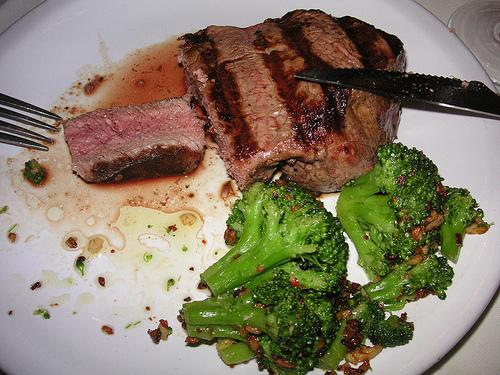Question: how many utensils?
Choices:
A. One.
B. None.
C. Two.
D. Three.
Answer with the letter. Answer: C Question: what is on the plate?
Choices:
A. Beads.
B. Chips.
C. Food.
D. Chicken.
Answer with the letter. Answer: C Question: what is on the left top of the meat?
Choices:
A. Gravy.
B. Potato's.
C. A knife.
D. Peas.
Answer with the letter. Answer: C Question: what color are the utensils?
Choices:
A. Silver.
B. Gold.
C. White.
D. Yellow.
Answer with the letter. Answer: A 